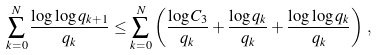<formula> <loc_0><loc_0><loc_500><loc_500>\sum _ { k = 0 } ^ { N } \frac { \log \log q _ { k + 1 } } { q _ { k } } \leq \sum _ { k = 0 } ^ { N } \left ( \frac { \log C _ { 3 } } { q _ { k } } + \frac { \log q _ { k } } { q _ { k } } + \frac { \log \log q _ { k } } { q _ { k } } \right ) \, ,</formula> 